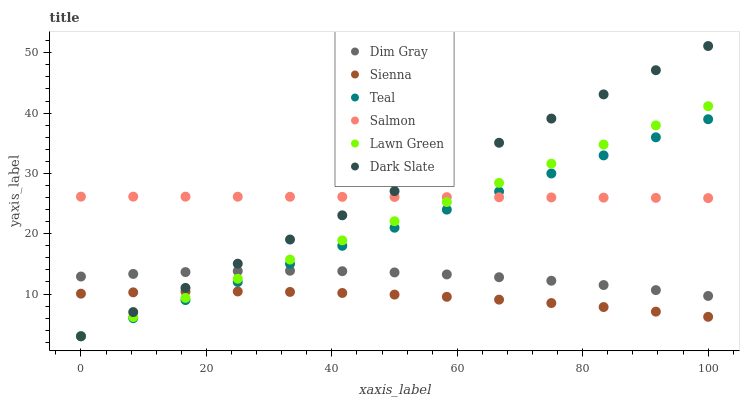Does Sienna have the minimum area under the curve?
Answer yes or no. Yes. Does Dark Slate have the maximum area under the curve?
Answer yes or no. Yes. Does Dim Gray have the minimum area under the curve?
Answer yes or no. No. Does Dim Gray have the maximum area under the curve?
Answer yes or no. No. Is Lawn Green the smoothest?
Answer yes or no. Yes. Is Dim Gray the roughest?
Answer yes or no. Yes. Is Salmon the smoothest?
Answer yes or no. No. Is Salmon the roughest?
Answer yes or no. No. Does Lawn Green have the lowest value?
Answer yes or no. Yes. Does Dim Gray have the lowest value?
Answer yes or no. No. Does Dark Slate have the highest value?
Answer yes or no. Yes. Does Dim Gray have the highest value?
Answer yes or no. No. Is Sienna less than Dim Gray?
Answer yes or no. Yes. Is Dim Gray greater than Sienna?
Answer yes or no. Yes. Does Sienna intersect Dark Slate?
Answer yes or no. Yes. Is Sienna less than Dark Slate?
Answer yes or no. No. Is Sienna greater than Dark Slate?
Answer yes or no. No. Does Sienna intersect Dim Gray?
Answer yes or no. No. 